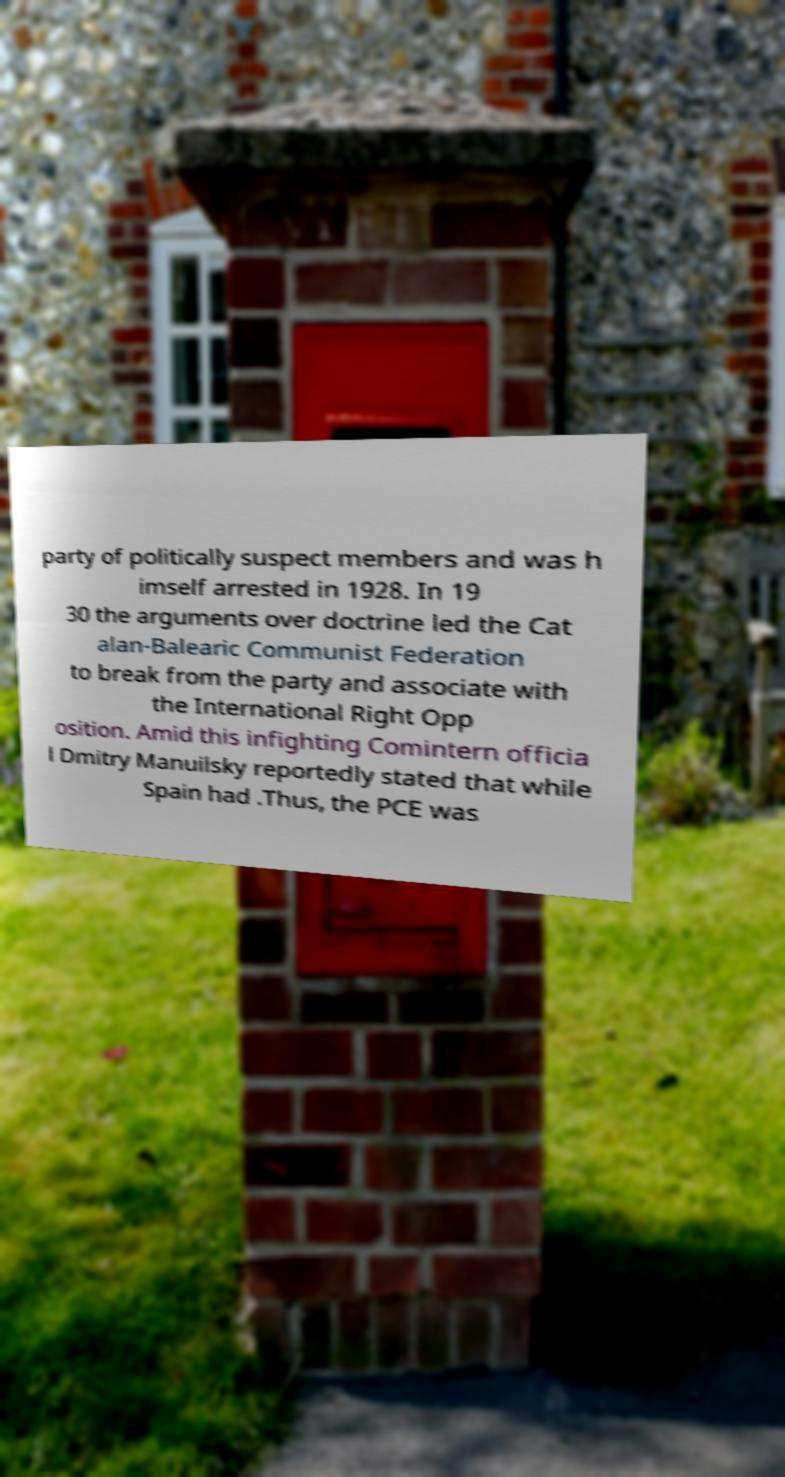I need the written content from this picture converted into text. Can you do that? party of politically suspect members and was h imself arrested in 1928. In 19 30 the arguments over doctrine led the Cat alan-Balearic Communist Federation to break from the party and associate with the International Right Opp osition. Amid this infighting Comintern officia l Dmitry Manuilsky reportedly stated that while Spain had .Thus, the PCE was 